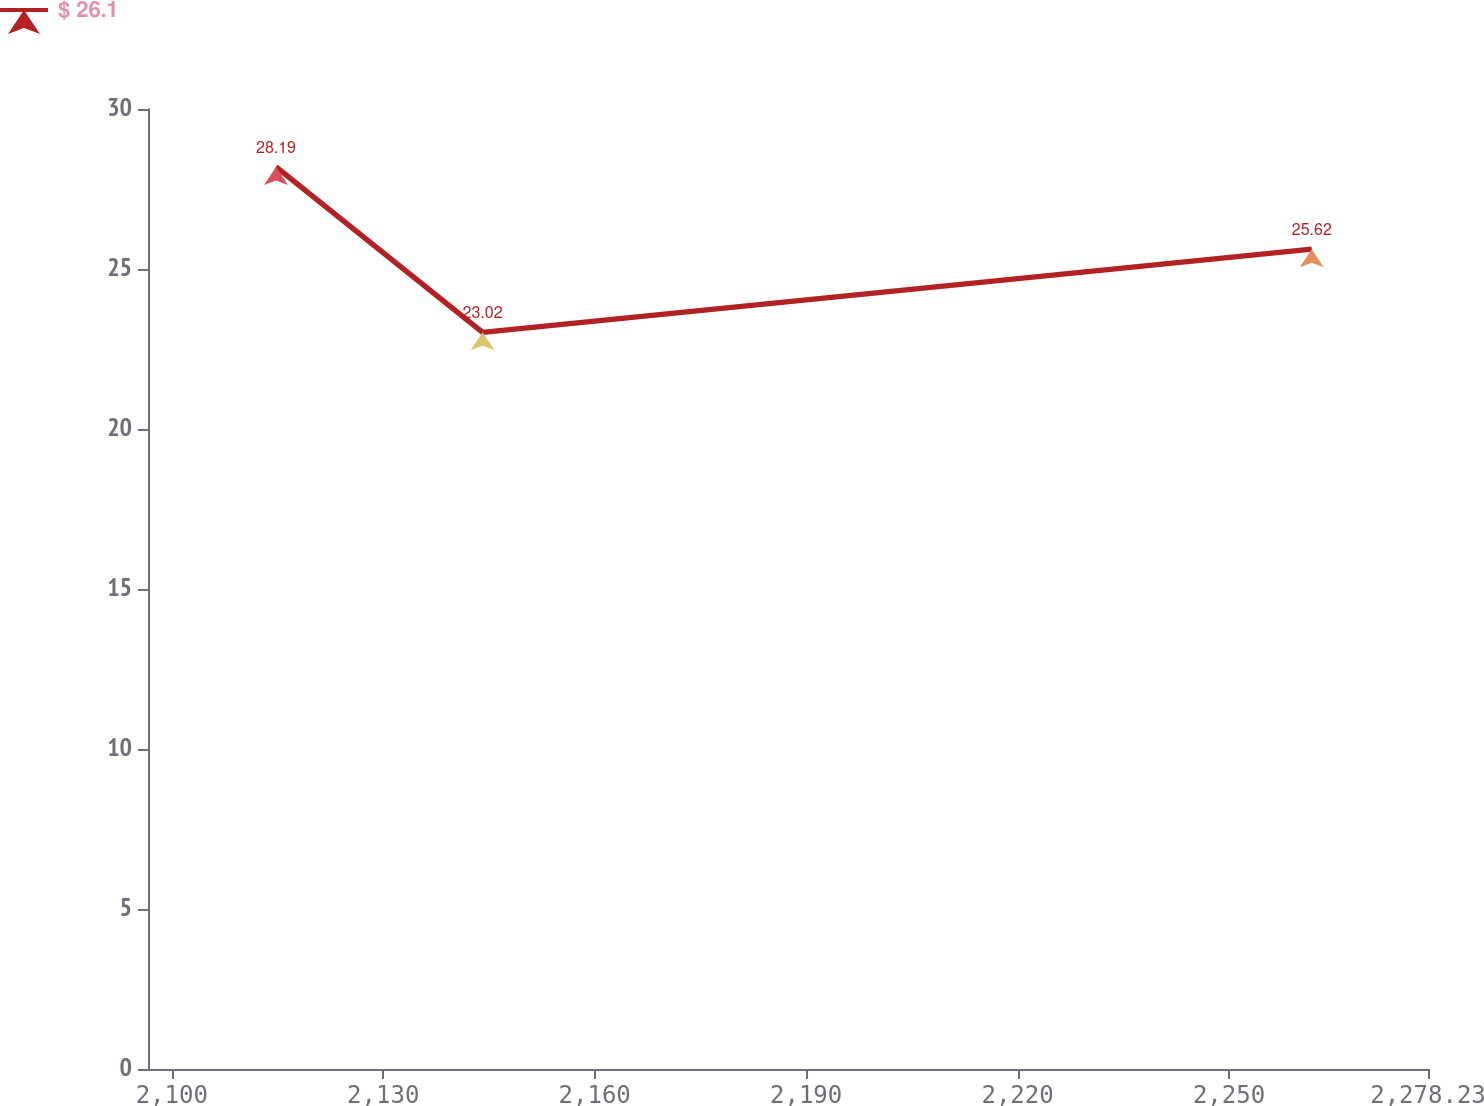Convert chart. <chart><loc_0><loc_0><loc_500><loc_500><line_chart><ecel><fcel>$ 26.1<nl><fcel>2114.79<fcel>28.19<nl><fcel>2144.1<fcel>23.02<nl><fcel>2261.74<fcel>25.62<nl><fcel>2296.39<fcel>18.72<nl></chart> 